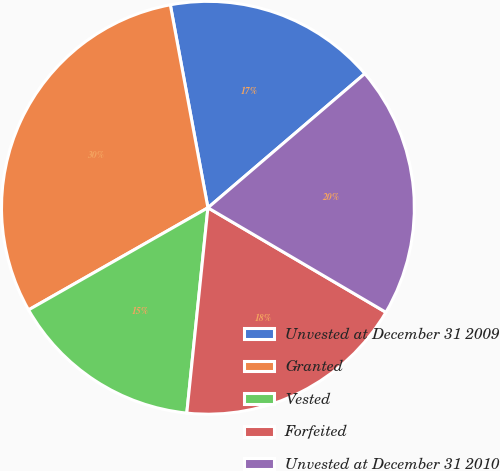Convert chart. <chart><loc_0><loc_0><loc_500><loc_500><pie_chart><fcel>Unvested at December 31 2009<fcel>Granted<fcel>Vested<fcel>Forfeited<fcel>Unvested at December 31 2010<nl><fcel>16.66%<fcel>30.32%<fcel>15.13%<fcel>18.18%<fcel>19.71%<nl></chart> 